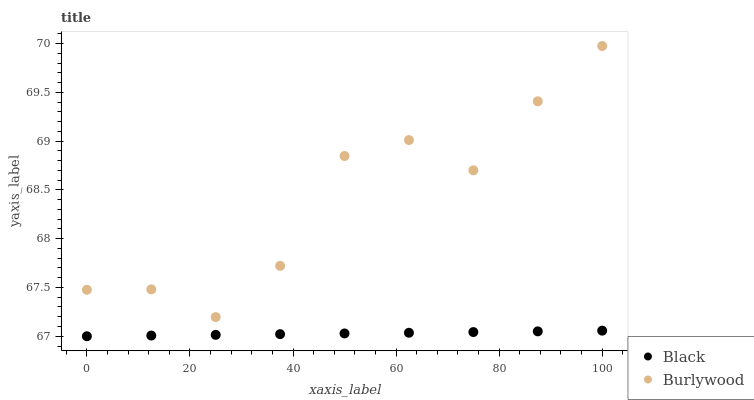Does Black have the minimum area under the curve?
Answer yes or no. Yes. Does Burlywood have the maximum area under the curve?
Answer yes or no. Yes. Does Black have the maximum area under the curve?
Answer yes or no. No. Is Black the smoothest?
Answer yes or no. Yes. Is Burlywood the roughest?
Answer yes or no. Yes. Is Black the roughest?
Answer yes or no. No. Does Black have the lowest value?
Answer yes or no. Yes. Does Burlywood have the highest value?
Answer yes or no. Yes. Does Black have the highest value?
Answer yes or no. No. Is Black less than Burlywood?
Answer yes or no. Yes. Is Burlywood greater than Black?
Answer yes or no. Yes. Does Black intersect Burlywood?
Answer yes or no. No. 